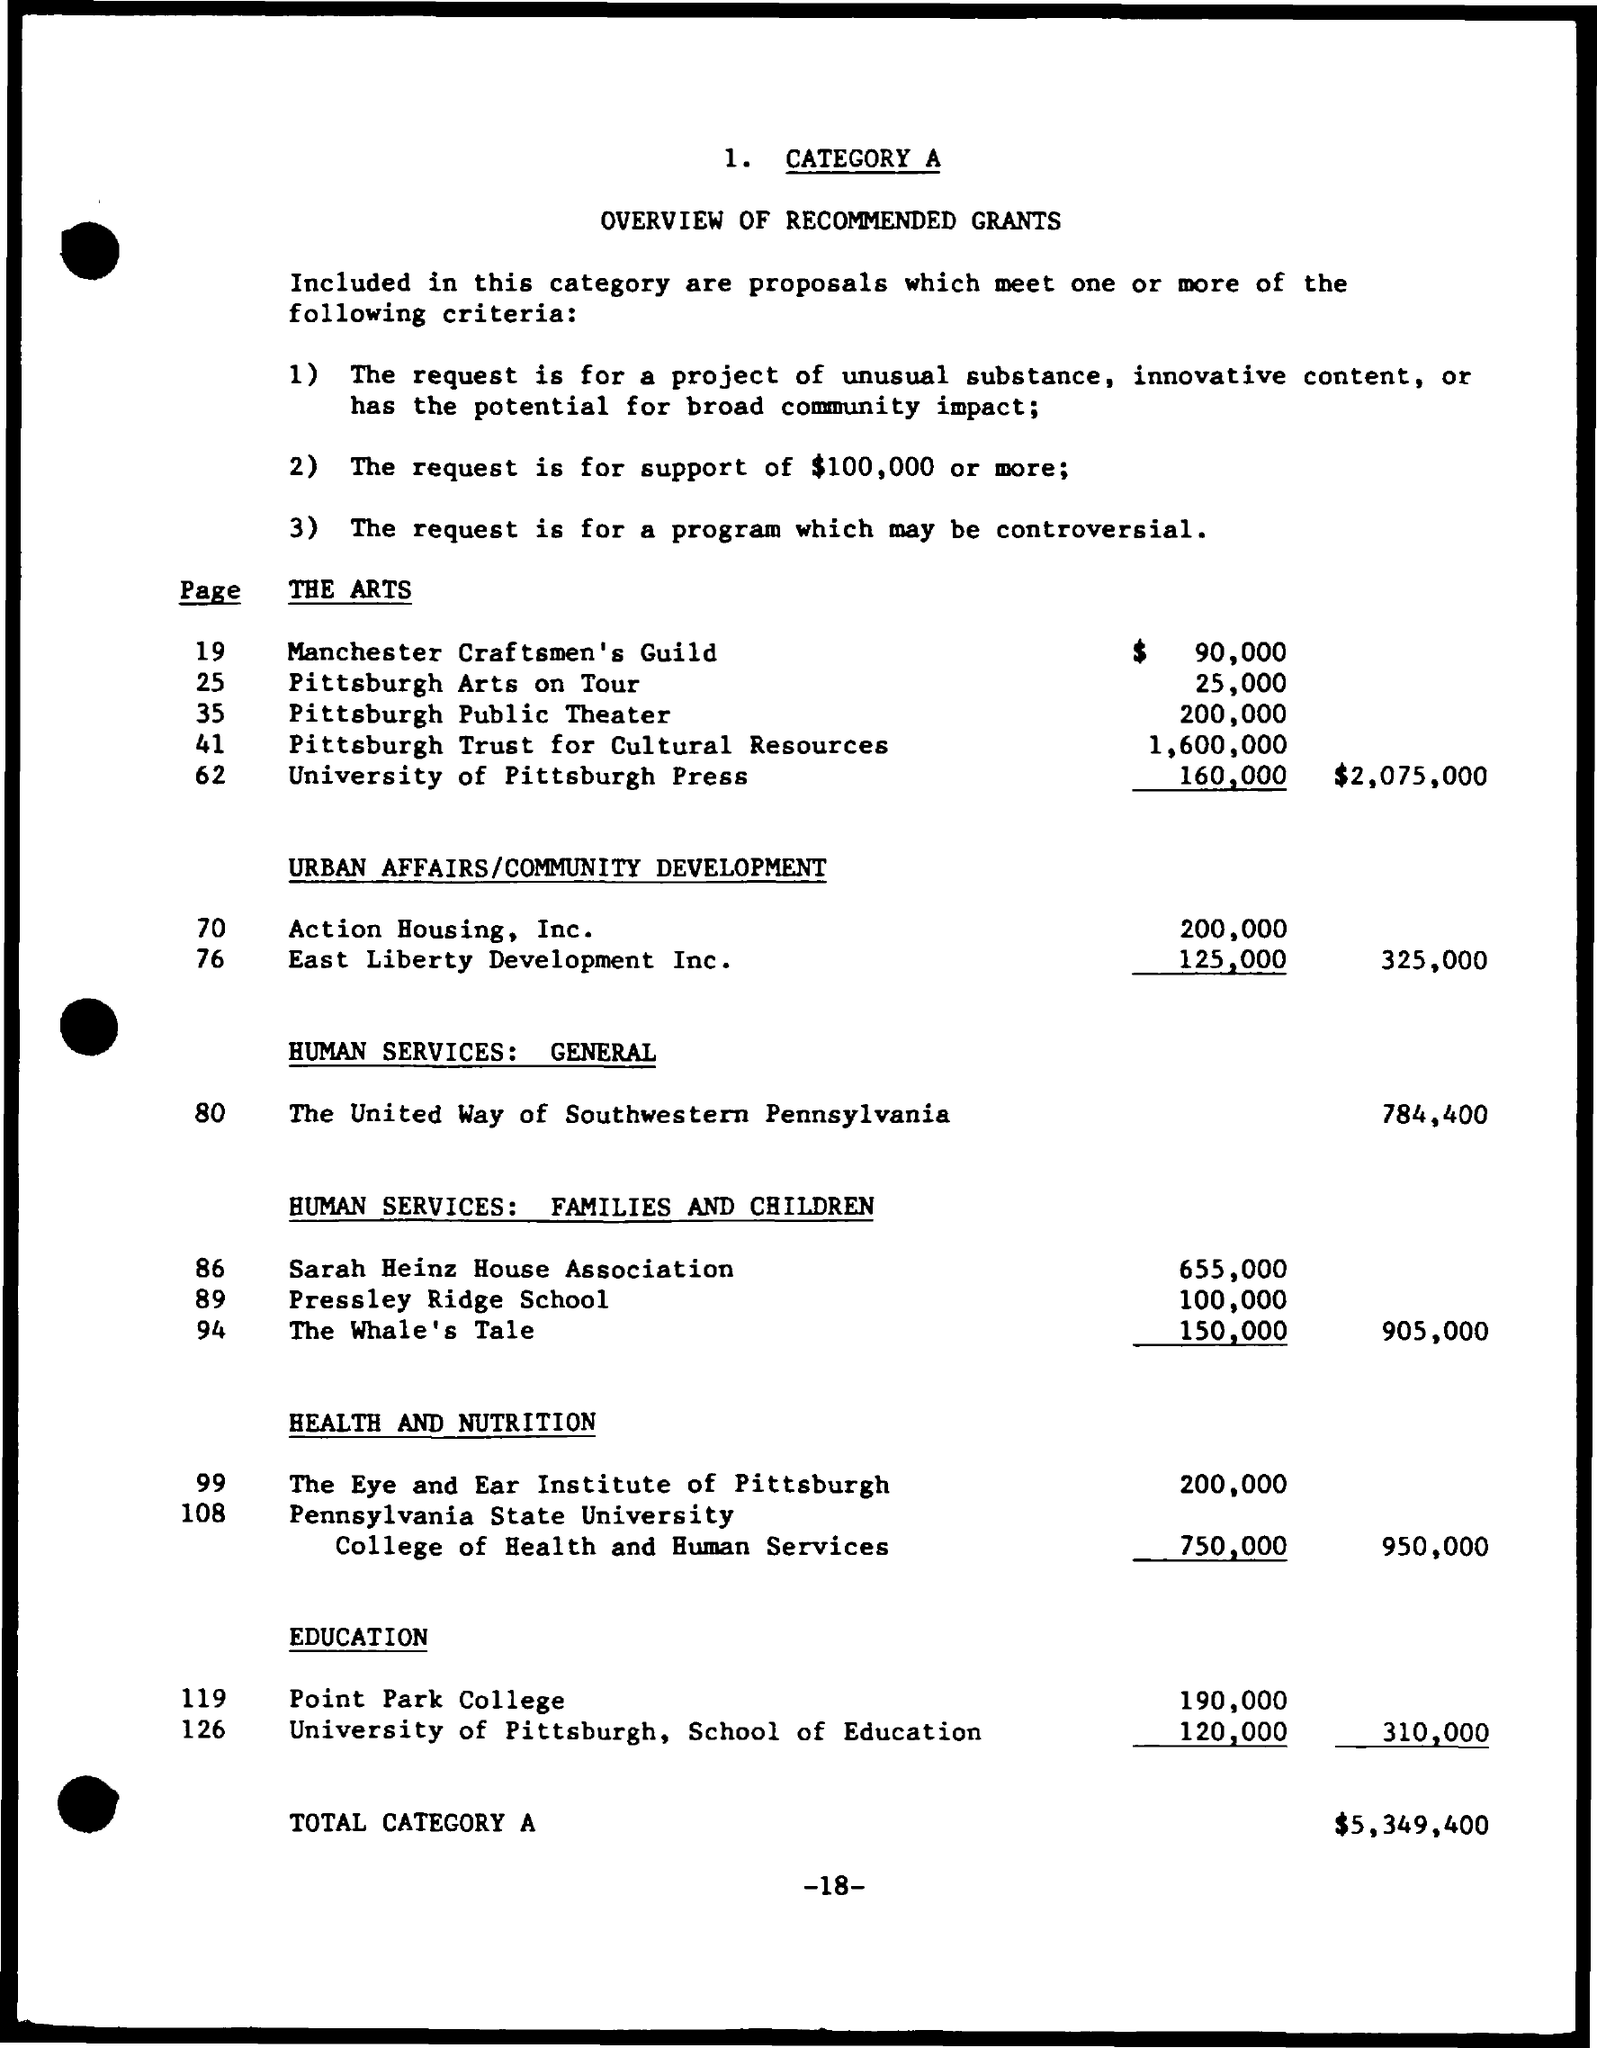Highlight a few significant elements in this photo. The page number is 18. 